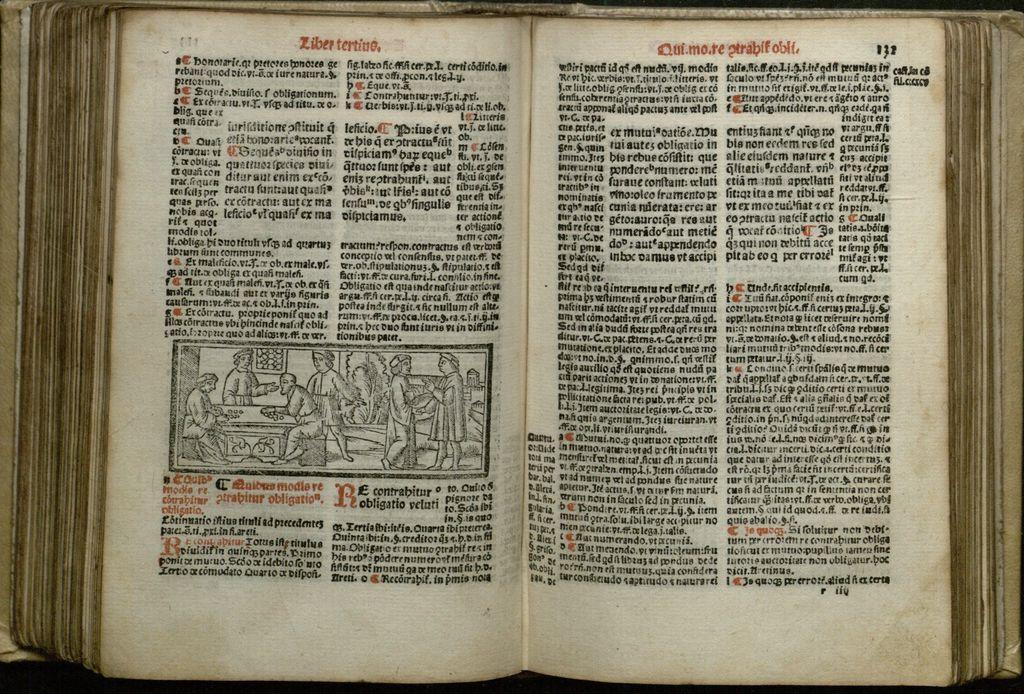What page is this book on?
Offer a very short reply. 132. 